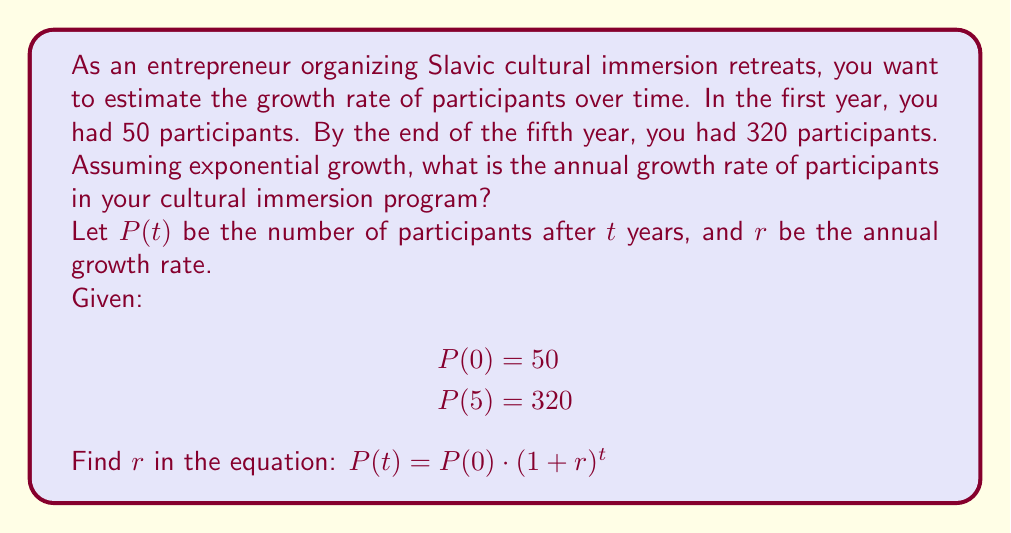Show me your answer to this math problem. To solve this problem, we'll use the exponential growth formula and the given information:

1) The general formula for exponential growth is:
   $P(t) = P(0) \cdot (1+r)^t$

2) We know that:
   $P(0) = 50$ (initial number of participants)
   $P(5) = 320$ (number of participants after 5 years)

3) Substituting these values into the formula:
   $320 = 50 \cdot (1+r)^5$

4) Divide both sides by 50:
   $\frac{320}{50} = (1+r)^5$
   $6.4 = (1+r)^5$

5) Take the fifth root of both sides:
   $\sqrt[5]{6.4} = 1+r$

6) Solve for $r$:
   $\sqrt[5]{6.4} - 1 = r$
   $1.4491 - 1 = r$
   $r = 0.4491$

7) Convert to a percentage:
   $r = 0.4491 \cdot 100\% = 44.91\%$

Therefore, the annual growth rate of participants is approximately 44.91%.
Answer: The annual growth rate of participants in the cultural immersion program is approximately 44.91%. 